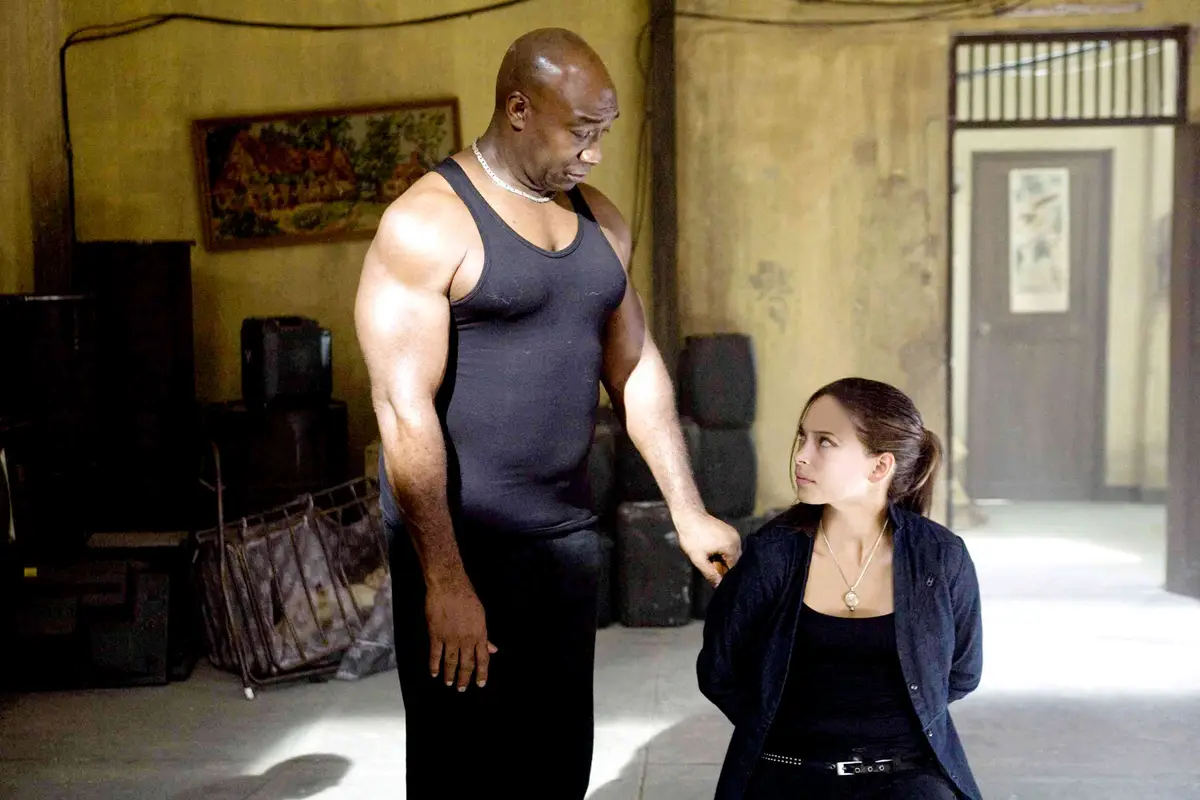Analyze the image in a comprehensive and detailed manner.
 In this evocative image, we see the late actor Michael Clarke Duncan, standing on the left, clad in a black tank top. His towering figure and muscular build are evident as he looks down with a gentle expression. On the right, young actress AnnaSophia Robb is seated, wearing a black jacket. The two are engaged in what appears to be a serious conversation, set against the backdrop of a room that has seen better days, complete with a worn-out door and a window. 